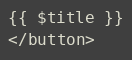Convert code to text. <code><loc_0><loc_0><loc_500><loc_500><_PHP_>{{ $title }}
</button></code> 